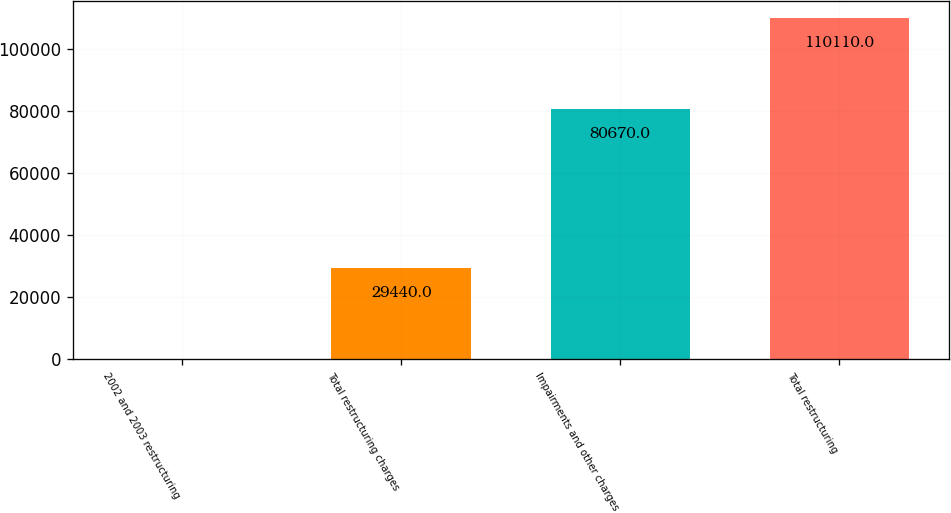Convert chart. <chart><loc_0><loc_0><loc_500><loc_500><bar_chart><fcel>2002 and 2003 restructuring<fcel>Total restructuring charges<fcel>Impairments and other charges<fcel>Total restructuring<nl><fcel>175<fcel>29440<fcel>80670<fcel>110110<nl></chart> 